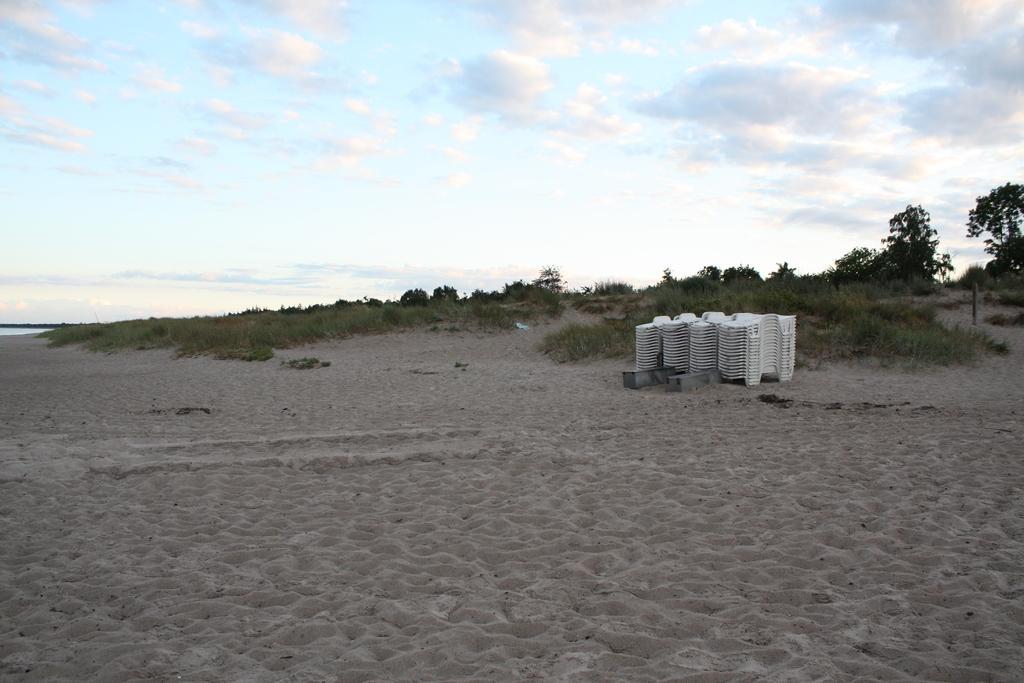Please provide a concise description of this image. In this image in the center there is a white colour object. In the background there are trees. On the ground there is grass and the sky is cloudy. In the front on the ground there is sand. 